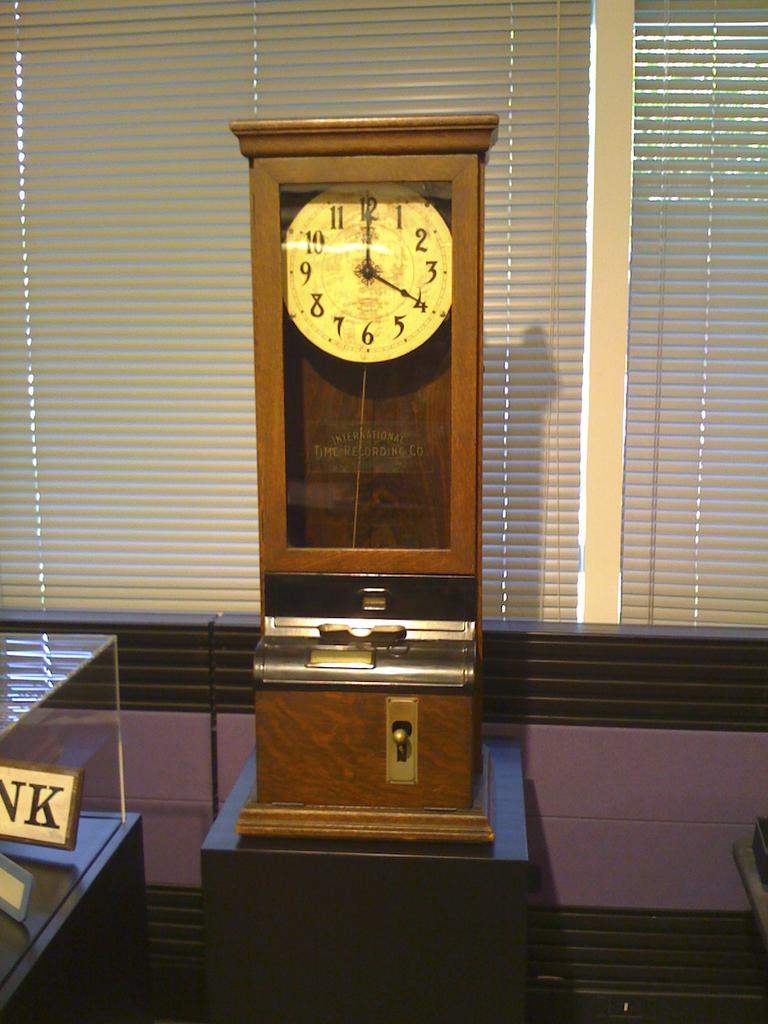What is the main object in the middle of the picture? There is a clock in the middle of the picture. What can be seen in the background of the picture? There are window blinds in the background of the picture. How many sisters are sitting on the iron in the picture? There are no sisters or iron present in the picture. 